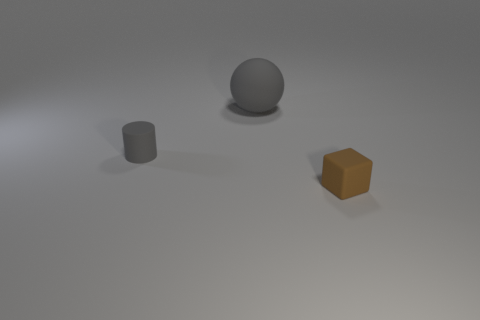Add 1 small shiny blocks. How many objects exist? 4 Subtract all cubes. How many objects are left? 2 Add 1 rubber cylinders. How many rubber cylinders exist? 2 Subtract 0 green blocks. How many objects are left? 3 Subtract all tiny brown things. Subtract all big blue matte objects. How many objects are left? 2 Add 1 small gray rubber objects. How many small gray rubber objects are left? 2 